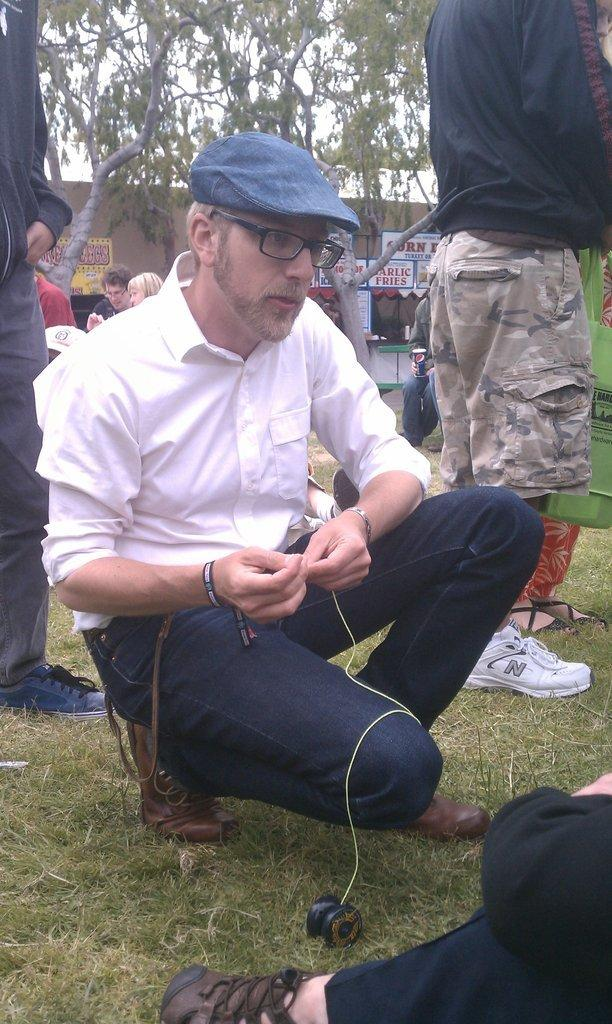What is the person in the foreground of the image doing? The person is sitting on the grass in the image. What can be seen in the background of the image? There are persons, a store, trees, a wall, and the sky visible in the background of the image. How many people are visible in the background? There are persons visible in the background of the image, but the exact number cannot be determined from the provided facts. What type of structure is present in the background of the image? There is a store in the background of the image. What type of quartz can be seen on the person's head in the image? There is no quartz visible on the person's head in the image. Are there any frogs visible in the image? There is no mention of frogs in the provided facts, so it cannot be determined if any are present in the image. 